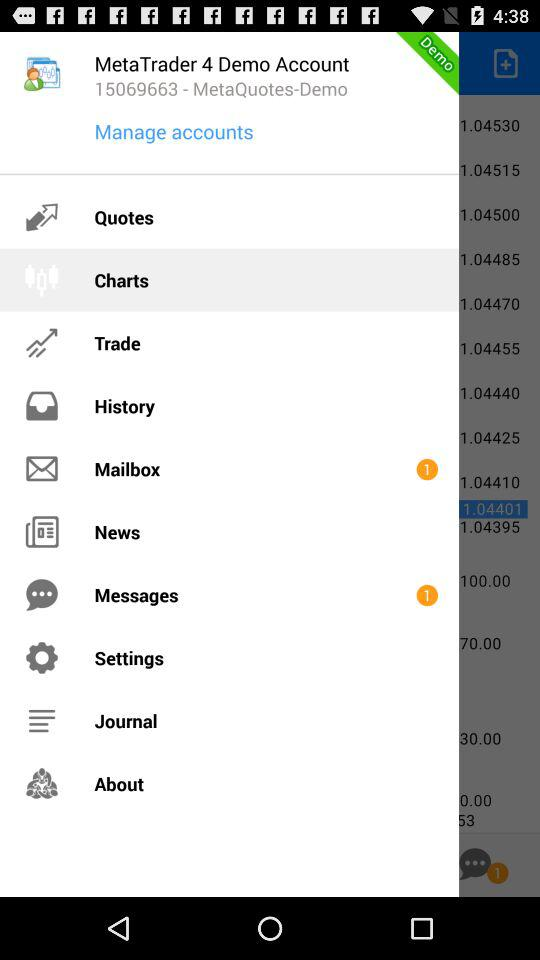How many unread mails are there in "Mailbox"? There is 1 unread mail in "Mailbox". 